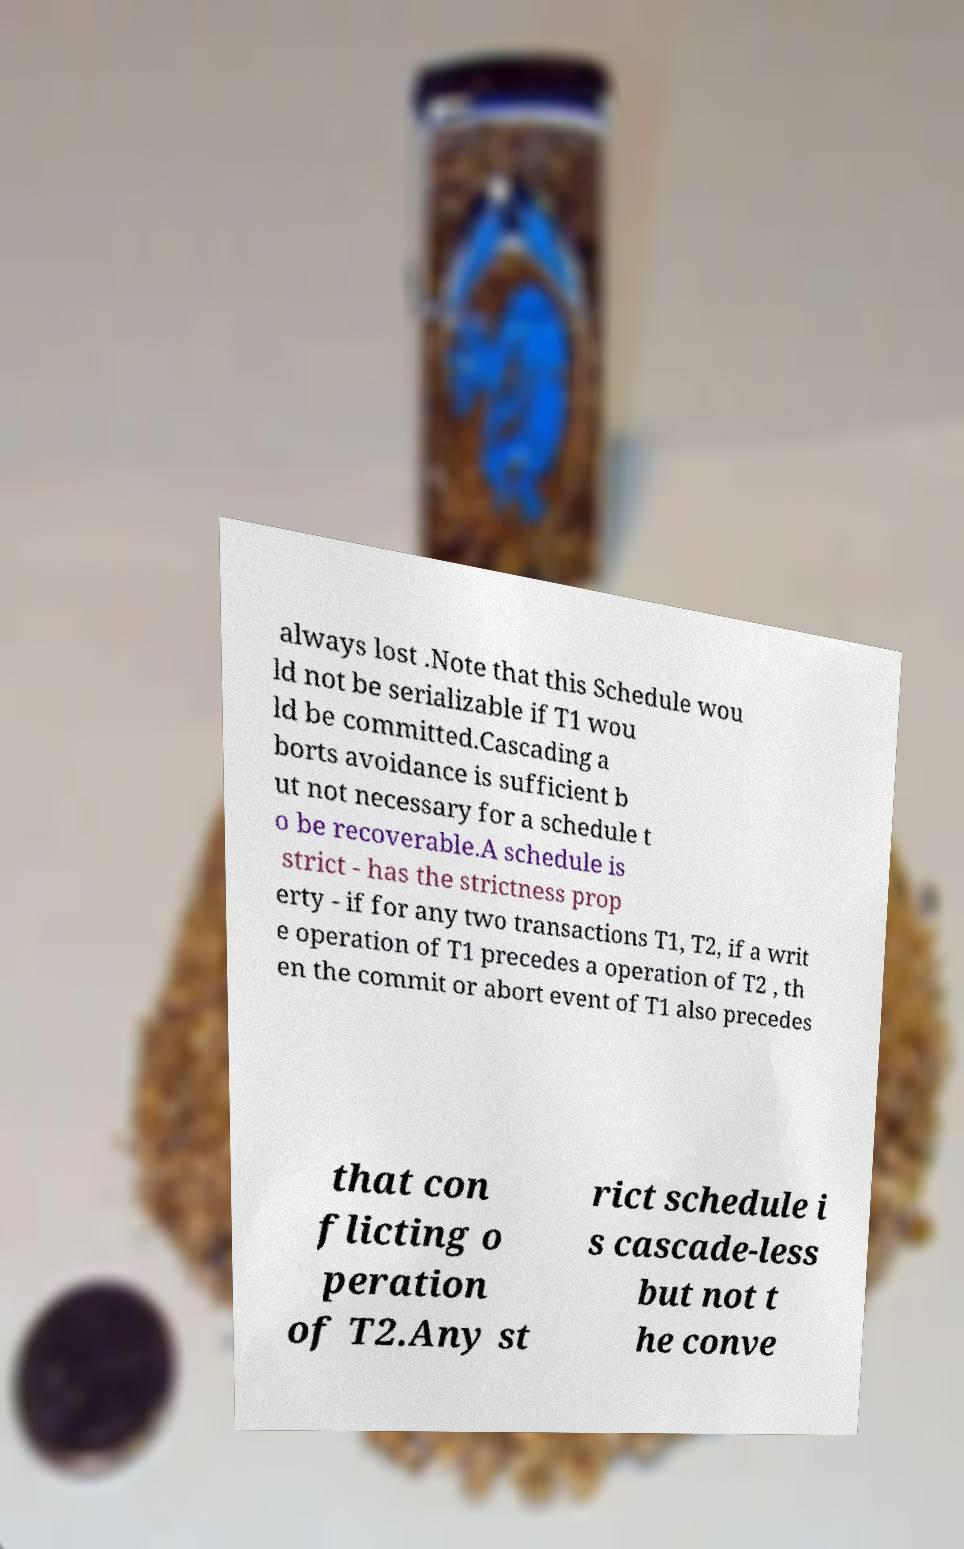Could you extract and type out the text from this image? always lost .Note that this Schedule wou ld not be serializable if T1 wou ld be committed.Cascading a borts avoidance is sufficient b ut not necessary for a schedule t o be recoverable.A schedule is strict - has the strictness prop erty - if for any two transactions T1, T2, if a writ e operation of T1 precedes a operation of T2 , th en the commit or abort event of T1 also precedes that con flicting o peration of T2.Any st rict schedule i s cascade-less but not t he conve 